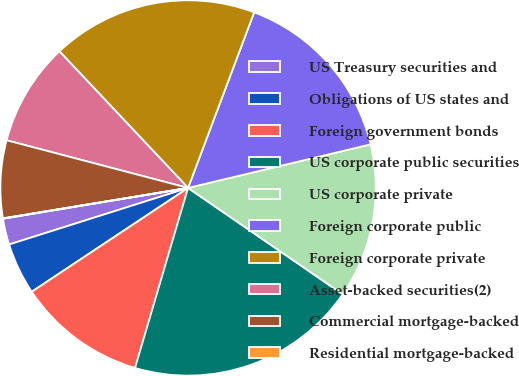Convert chart. <chart><loc_0><loc_0><loc_500><loc_500><pie_chart><fcel>US Treasury securities and<fcel>Obligations of US states and<fcel>Foreign government bonds<fcel>US corporate public securities<fcel>US corporate private<fcel>Foreign corporate public<fcel>Foreign corporate private<fcel>Asset-backed securities(2)<fcel>Commercial mortgage-backed<fcel>Residential mortgage-backed<nl><fcel>2.25%<fcel>4.46%<fcel>11.11%<fcel>19.97%<fcel>13.32%<fcel>15.54%<fcel>17.75%<fcel>8.89%<fcel>6.68%<fcel>0.03%<nl></chart> 